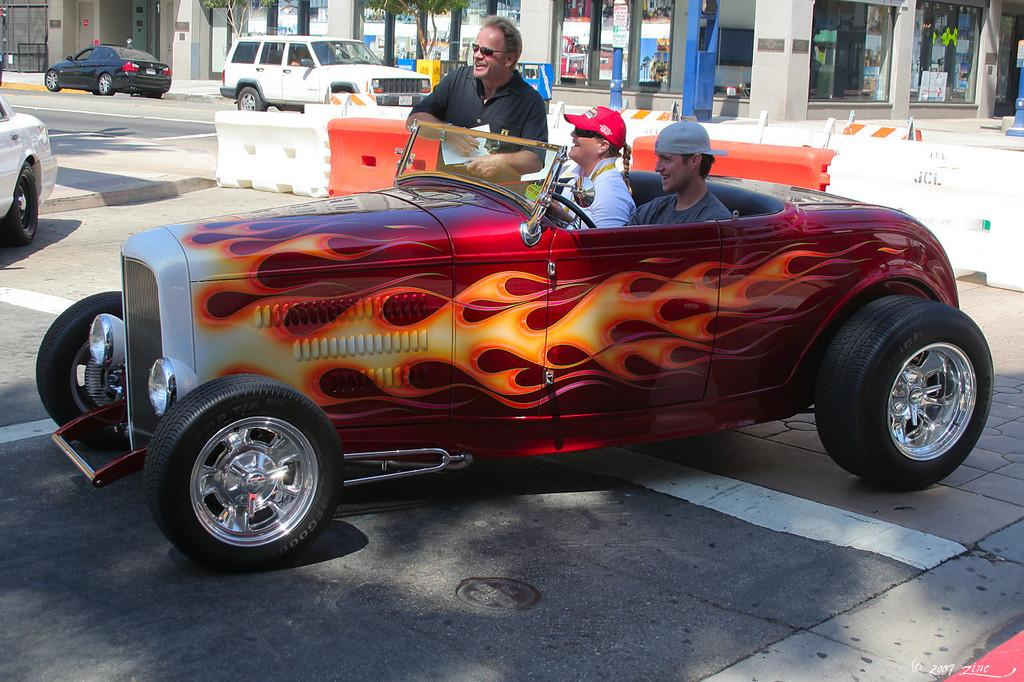How many people are sitting in the car in the image? There are two persons sitting in a car in the image. What is the person in the image not doing? The person is not sitting in the car; they are standing. What can be seen in the background of the image? There are cars visible in the background and a building. What type of cactus can be seen growing in the car in the image? There is no cactus present in the car or the image. Is there a rainstorm occurring in the image? There is no indication of a rainstorm in the image. 